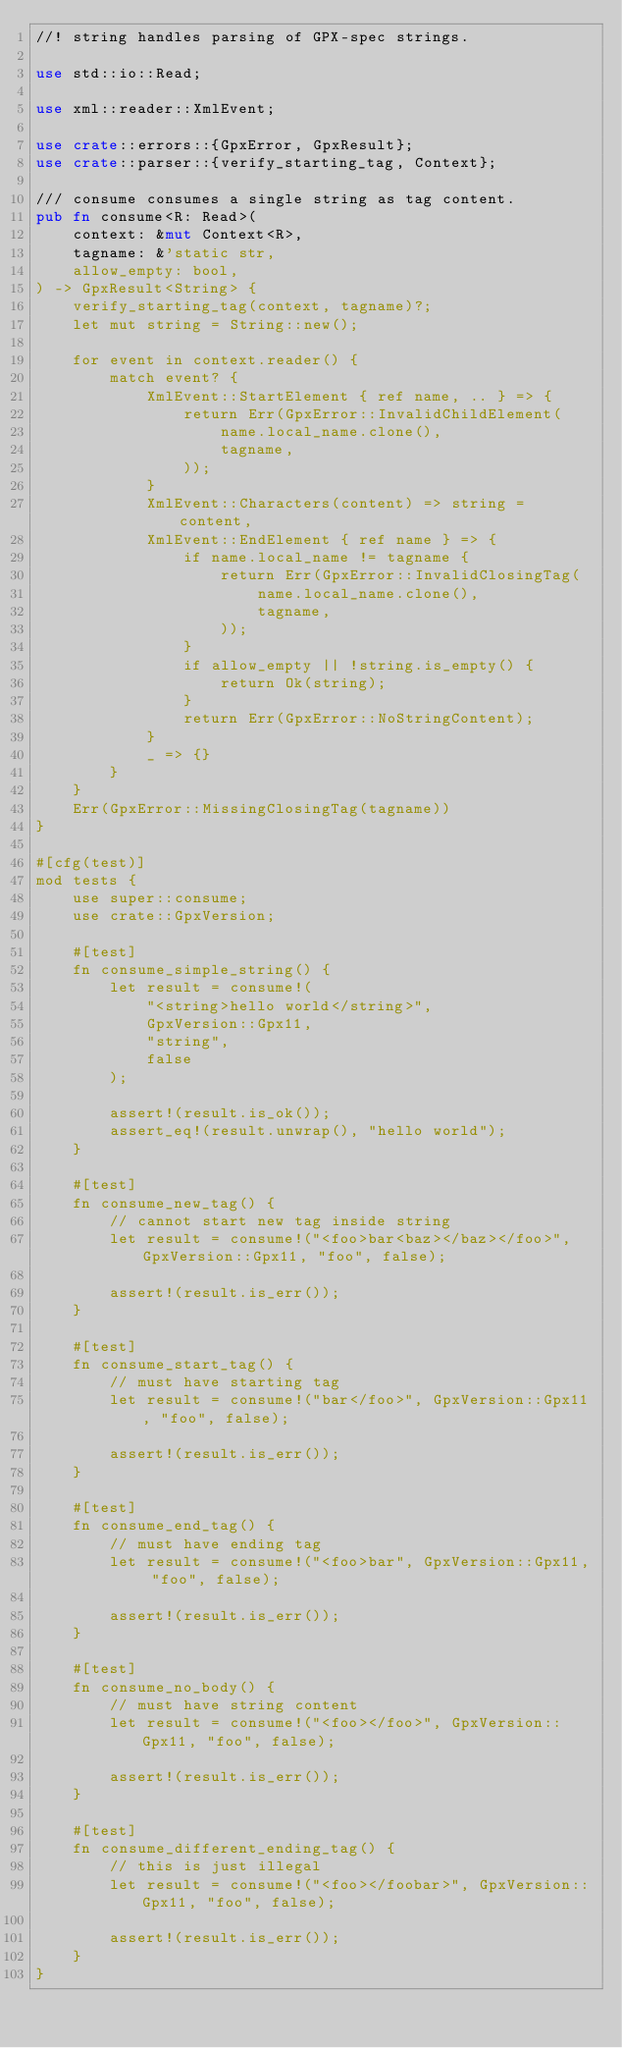<code> <loc_0><loc_0><loc_500><loc_500><_Rust_>//! string handles parsing of GPX-spec strings.

use std::io::Read;

use xml::reader::XmlEvent;

use crate::errors::{GpxError, GpxResult};
use crate::parser::{verify_starting_tag, Context};

/// consume consumes a single string as tag content.
pub fn consume<R: Read>(
    context: &mut Context<R>,
    tagname: &'static str,
    allow_empty: bool,
) -> GpxResult<String> {
    verify_starting_tag(context, tagname)?;
    let mut string = String::new();

    for event in context.reader() {
        match event? {
            XmlEvent::StartElement { ref name, .. } => {
                return Err(GpxError::InvalidChildElement(
                    name.local_name.clone(),
                    tagname,
                ));
            }
            XmlEvent::Characters(content) => string = content,
            XmlEvent::EndElement { ref name } => {
                if name.local_name != tagname {
                    return Err(GpxError::InvalidClosingTag(
                        name.local_name.clone(),
                        tagname,
                    ));
                }
                if allow_empty || !string.is_empty() {
                    return Ok(string);
                }
                return Err(GpxError::NoStringContent);
            }
            _ => {}
        }
    }
    Err(GpxError::MissingClosingTag(tagname))
}

#[cfg(test)]
mod tests {
    use super::consume;
    use crate::GpxVersion;

    #[test]
    fn consume_simple_string() {
        let result = consume!(
            "<string>hello world</string>",
            GpxVersion::Gpx11,
            "string",
            false
        );

        assert!(result.is_ok());
        assert_eq!(result.unwrap(), "hello world");
    }

    #[test]
    fn consume_new_tag() {
        // cannot start new tag inside string
        let result = consume!("<foo>bar<baz></baz></foo>", GpxVersion::Gpx11, "foo", false);

        assert!(result.is_err());
    }

    #[test]
    fn consume_start_tag() {
        // must have starting tag
        let result = consume!("bar</foo>", GpxVersion::Gpx11, "foo", false);

        assert!(result.is_err());
    }

    #[test]
    fn consume_end_tag() {
        // must have ending tag
        let result = consume!("<foo>bar", GpxVersion::Gpx11, "foo", false);

        assert!(result.is_err());
    }

    #[test]
    fn consume_no_body() {
        // must have string content
        let result = consume!("<foo></foo>", GpxVersion::Gpx11, "foo", false);

        assert!(result.is_err());
    }

    #[test]
    fn consume_different_ending_tag() {
        // this is just illegal
        let result = consume!("<foo></foobar>", GpxVersion::Gpx11, "foo", false);

        assert!(result.is_err());
    }
}
</code> 